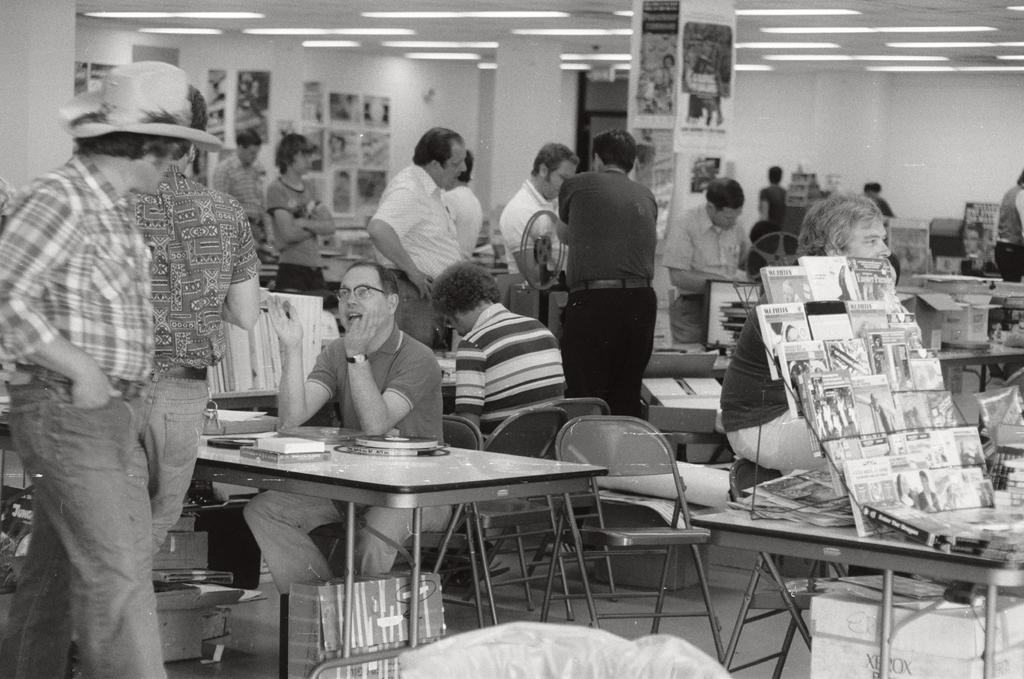How would you summarize this image in a sentence or two? In the image we can see there are people who are sitting on a table and there are people who are standing at the back and over here there is a book stand on which books are kept and on the top there are lightings. 